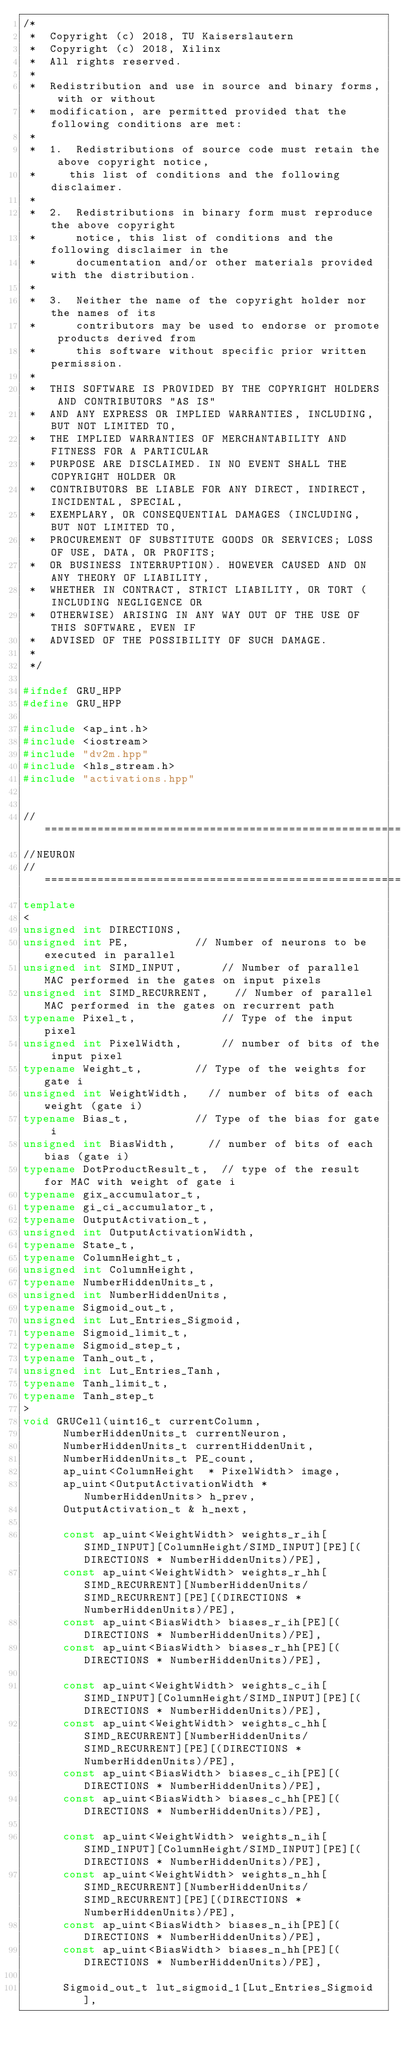<code> <loc_0><loc_0><loc_500><loc_500><_C++_>/*
 *  Copyright (c) 2018, TU Kaiserslautern
 *	Copyright (c) 2018, Xilinx
 *  All rights reserved.
 *
 *  Redistribution and use in source and binary forms, with or without
 *  modification, are permitted provided that the following conditions are met:
 *
 *  1.  Redistributions of source code must retain the above copyright notice,
 *     this list of conditions and the following disclaimer.
 *
 *  2.  Redistributions in binary form must reproduce the above copyright
 *      notice, this list of conditions and the following disclaimer in the
 *      documentation and/or other materials provided with the distribution.
 *
 *  3.  Neither the name of the copyright holder nor the names of its
 *      contributors may be used to endorse or promote products derived from
 *      this software without specific prior written permission.
 *
 *  THIS SOFTWARE IS PROVIDED BY THE COPYRIGHT HOLDERS AND CONTRIBUTORS "AS IS"
 *  AND ANY EXPRESS OR IMPLIED WARRANTIES, INCLUDING, BUT NOT LIMITED TO,
 *  THE IMPLIED WARRANTIES OF MERCHANTABILITY AND FITNESS FOR A PARTICULAR
 *  PURPOSE ARE DISCLAIMED. IN NO EVENT SHALL THE COPYRIGHT HOLDER OR
 *  CONTRIBUTORS BE LIABLE FOR ANY DIRECT, INDIRECT, INCIDENTAL, SPECIAL,
 *  EXEMPLARY, OR CONSEQUENTIAL DAMAGES (INCLUDING, BUT NOT LIMITED TO,
 *  PROCUREMENT OF SUBSTITUTE GOODS OR SERVICES; LOSS OF USE, DATA, OR PROFITS;
 *  OR BUSINESS INTERRUPTION). HOWEVER CAUSED AND ON ANY THEORY OF LIABILITY,
 *  WHETHER IN CONTRACT, STRICT LIABILITY, OR TORT (INCLUDING NEGLIGENCE OR
 *  OTHERWISE) ARISING IN ANY WAY OUT OF THE USE OF THIS SOFTWARE, EVEN IF
 *  ADVISED OF THE POSSIBILITY OF SUCH DAMAGE.
 *
 */

#ifndef GRU_HPP
#define GRU_HPP

#include <ap_int.h>
#include <iostream>
#include "dv2m.hpp"
#include <hls_stream.h>
#include "activations.hpp"


//===================================================================================================================================================================================
//NEURON
//===================================================================================================================================================================================
template
<
unsigned int DIRECTIONS, 
unsigned int PE,					// Number of neurons to be executed in parallel
unsigned int SIMD_INPUT, 			// Number of parallel MAC performed in the gates on input pixels
unsigned int SIMD_RECURRENT, 		// Number of parallel MAC performed in the gates on recurrent path
typename Pixel_t,     				// Type of the input pixel
unsigned int PixelWidth, 			// number of bits of the input pixel
typename Weight_t,				// Type of the weights for gate i
unsigned int WeightWidth,		// number of bits of each weight (gate i)
typename Bias_t,					// Type of the bias for gate i
unsigned int BiasWidth,			// number of bits of each bias (gate i)
typename DotProductResult_t, 	// type of the result for MAC with weight of gate i
typename gix_accumulator_t,
typename gi_ci_accumulator_t, 
typename OutputActivation_t,
unsigned int OutputActivationWidth,
typename State_t,
typename ColumnHeight_t,
unsigned int ColumnHeight,
typename NumberHiddenUnits_t,
unsigned int NumberHiddenUnits, 
typename Sigmoid_out_t,
unsigned int Lut_Entries_Sigmoid, 
typename Sigmoid_limit_t,
typename Sigmoid_step_t,
typename Tanh_out_t, 
unsigned int Lut_Entries_Tanh,
typename Tanh_limit_t,
typename Tanh_step_t
>
void GRUCell(uint16_t currentColumn,
			NumberHiddenUnits_t currentNeuron,
			NumberHiddenUnits_t currentHiddenUnit,
			NumberHiddenUnits_t PE_count,
			ap_uint<ColumnHeight  * PixelWidth> image,
			ap_uint<OutputActivationWidth * NumberHiddenUnits> h_prev,
			OutputActivation_t & h_next, 
			
			const ap_uint<WeightWidth> weights_r_ih[SIMD_INPUT][ColumnHeight/SIMD_INPUT][PE][(DIRECTIONS * NumberHiddenUnits)/PE],
			const ap_uint<WeightWidth> weights_r_hh[SIMD_RECURRENT][NumberHiddenUnits/SIMD_RECURRENT][PE][(DIRECTIONS * NumberHiddenUnits)/PE],
			const ap_uint<BiasWidth> biases_r_ih[PE][(DIRECTIONS * NumberHiddenUnits)/PE],
			const ap_uint<BiasWidth> biases_r_hh[PE][(DIRECTIONS * NumberHiddenUnits)/PE],			  

			const ap_uint<WeightWidth> weights_c_ih[SIMD_INPUT][ColumnHeight/SIMD_INPUT][PE][(DIRECTIONS * NumberHiddenUnits)/PE],
			const ap_uint<WeightWidth> weights_c_hh[SIMD_RECURRENT][NumberHiddenUnits/SIMD_RECURRENT][PE][(DIRECTIONS * NumberHiddenUnits)/PE],
			const ap_uint<BiasWidth> biases_c_ih[PE][(DIRECTIONS * NumberHiddenUnits)/PE],
			const ap_uint<BiasWidth> biases_c_hh[PE][(DIRECTIONS * NumberHiddenUnits)/PE],

			const ap_uint<WeightWidth> weights_n_ih[SIMD_INPUT][ColumnHeight/SIMD_INPUT][PE][(DIRECTIONS * NumberHiddenUnits)/PE], 
			const ap_uint<WeightWidth> weights_n_hh[SIMD_RECURRENT][NumberHiddenUnits/SIMD_RECURRENT][PE][(DIRECTIONS * NumberHiddenUnits)/PE],  
			const ap_uint<BiasWidth> biases_n_ih[PE][(DIRECTIONS * NumberHiddenUnits)/PE],
			const ap_uint<BiasWidth> biases_n_hh[PE][(DIRECTIONS * NumberHiddenUnits)/PE],
			
			Sigmoid_out_t lut_sigmoid_1[Lut_Entries_Sigmoid], </code> 